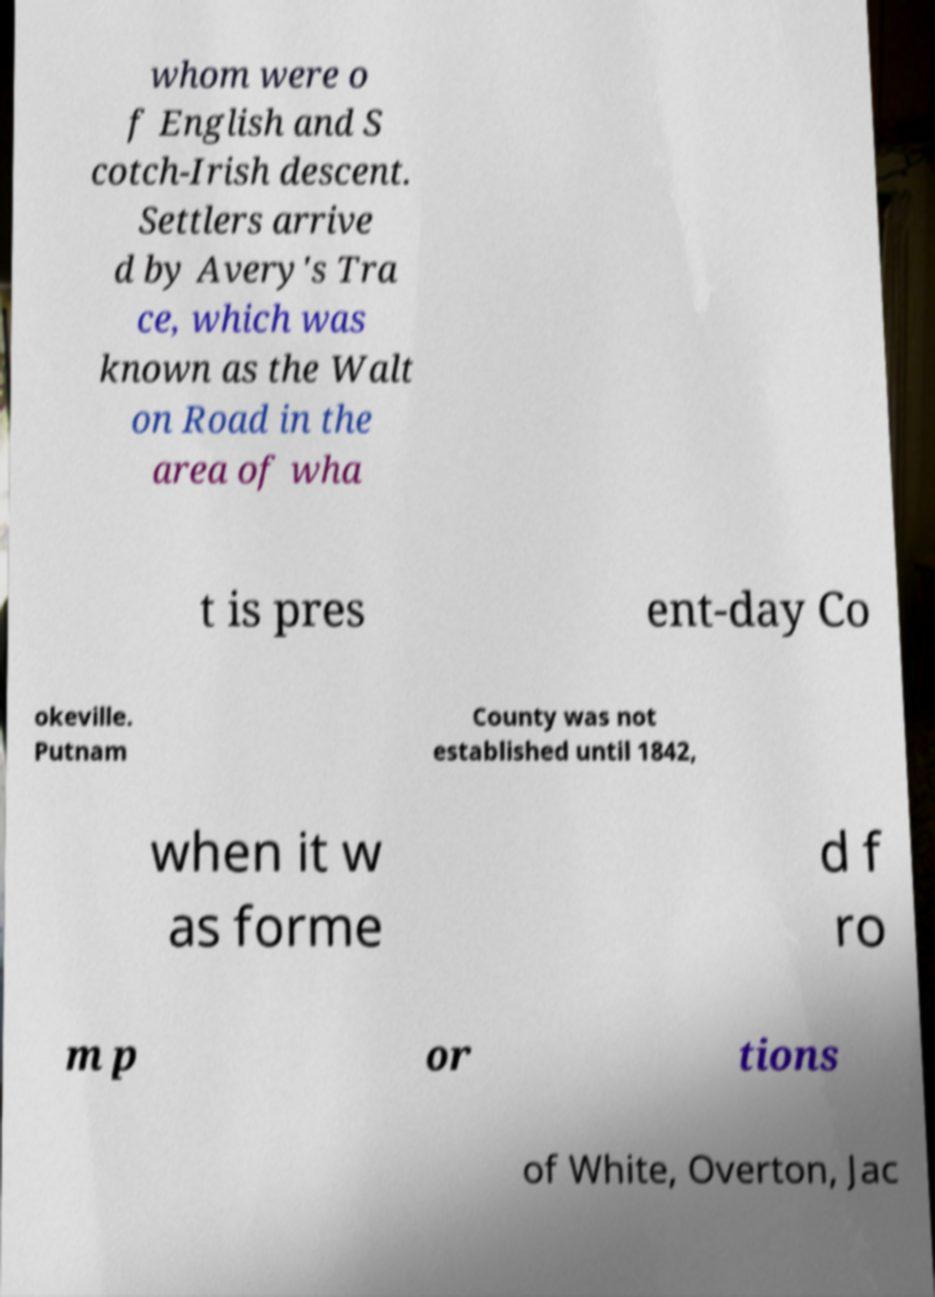Please identify and transcribe the text found in this image. whom were o f English and S cotch-Irish descent. Settlers arrive d by Avery's Tra ce, which was known as the Walt on Road in the area of wha t is pres ent-day Co okeville. Putnam County was not established until 1842, when it w as forme d f ro m p or tions of White, Overton, Jac 